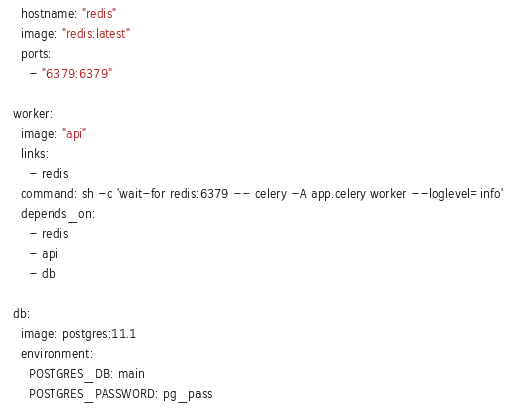<code> <loc_0><loc_0><loc_500><loc_500><_YAML_>    hostname: "redis"
    image: "redis:latest"
    ports:
      - "6379:6379"

  worker:
    image: "api"
    links:
      - redis
    command: sh -c 'wait-for redis:6379 -- celery -A app.celery worker --loglevel=info'
    depends_on:
      - redis
      - api
      - db

  db:
    image: postgres:11.1
    environment:
      POSTGRES_DB: main
      POSTGRES_PASSWORD: pg_pass
</code> 